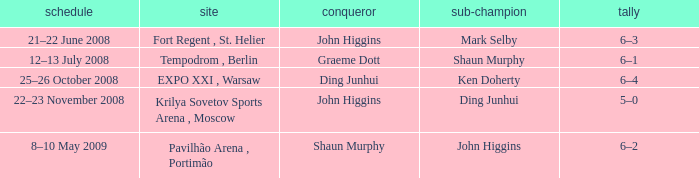When was the match that had Shaun Murphy as runner-up? 12–13 July 2008. 